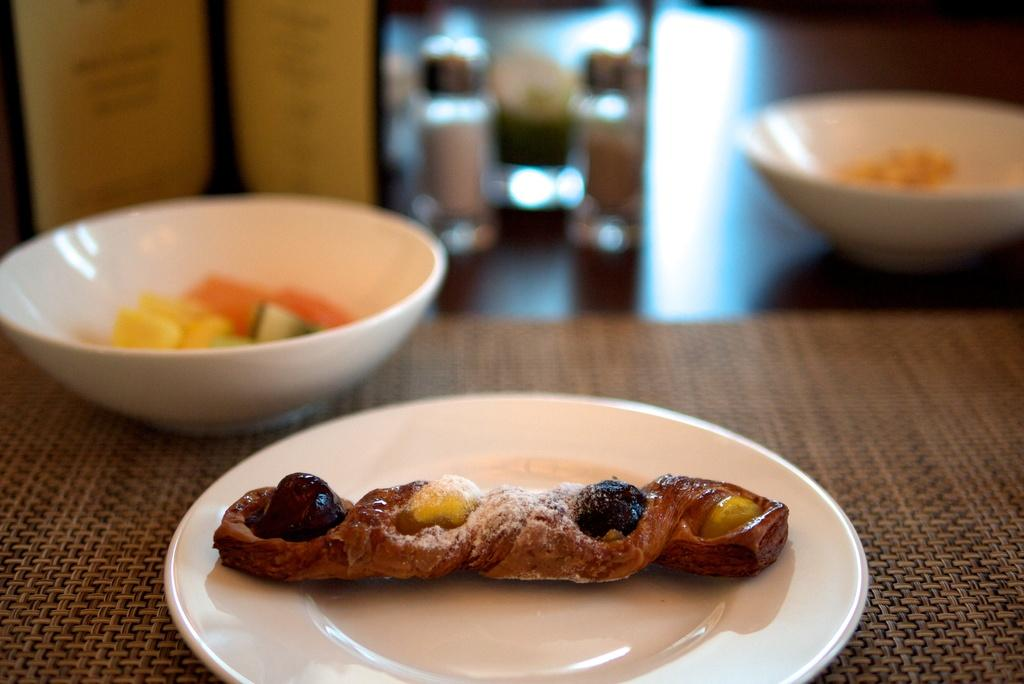What is the main subject on the plate in the image? There is a food item on a plate in the image, but the specific food item cannot be determined from the provided facts. What else is present on a surface in the image? There is a bowl on a surface in the image. Can you describe the background of the image? The background of the image is blurred. How many letters are visible in the tub in the image? There is no tub or letters present in the image. What type of net is being used to catch the fish in the image? There is no net or fish present in the image. 